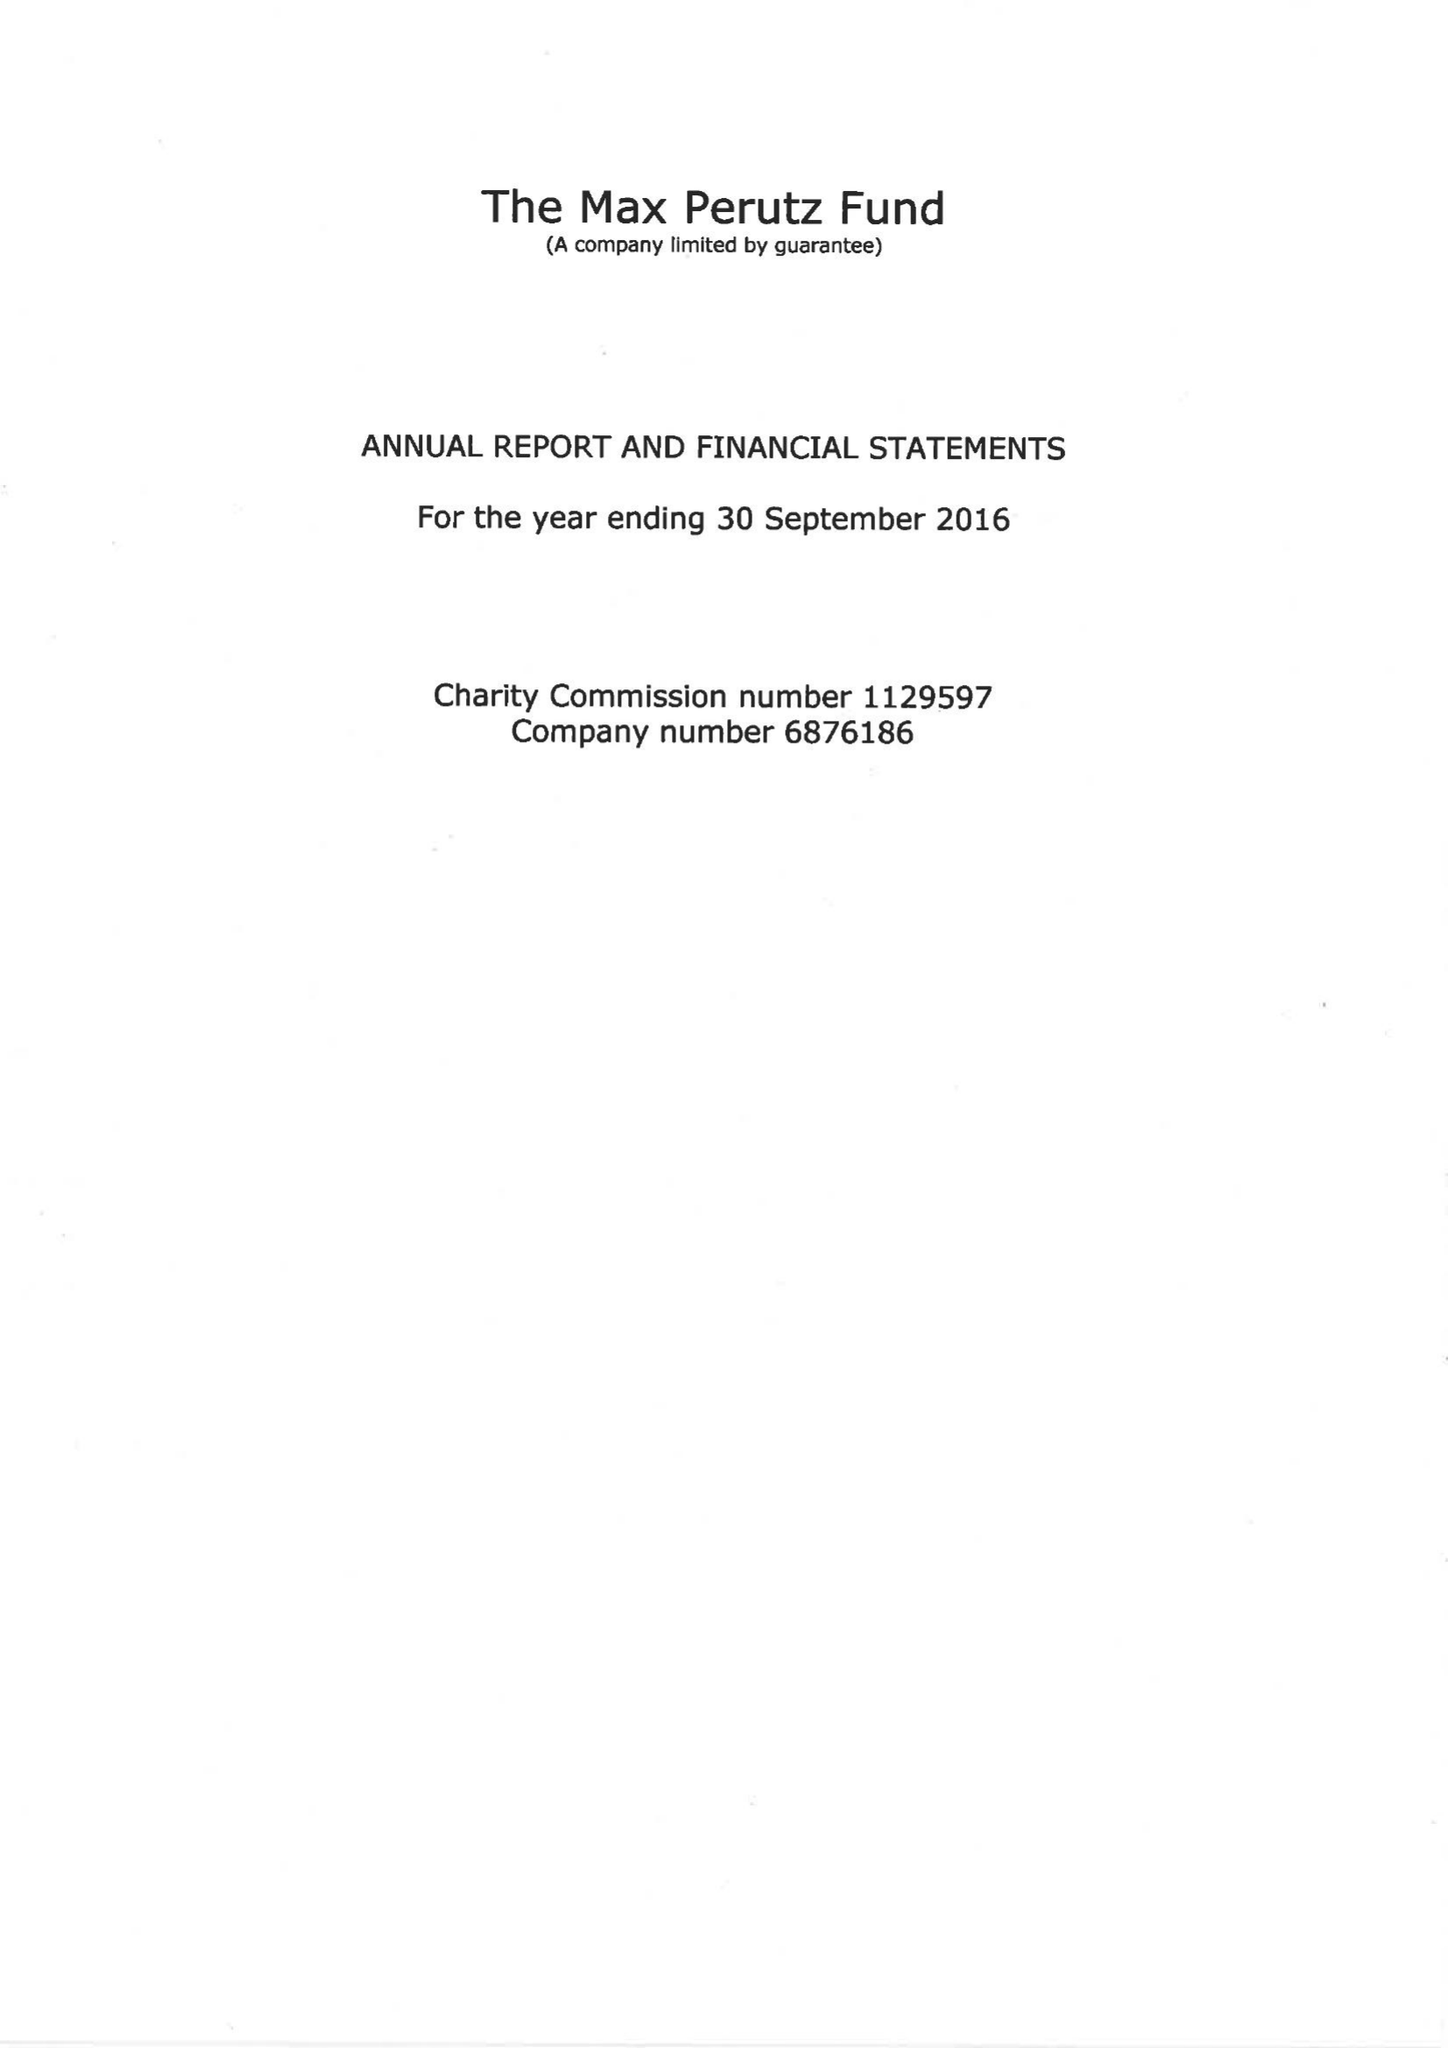What is the value for the address__street_line?
Answer the question using a single word or phrase. FRANCIS CRICK AVENUE 